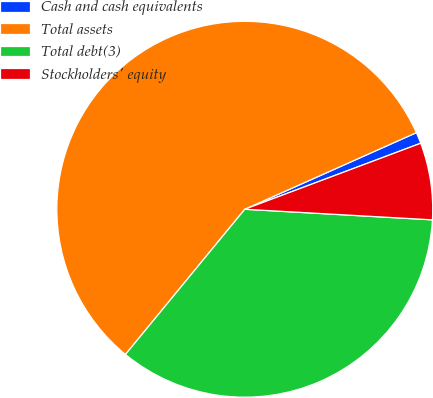<chart> <loc_0><loc_0><loc_500><loc_500><pie_chart><fcel>Cash and cash equivalents<fcel>Total assets<fcel>Total debt(3)<fcel>Stockholders' equity<nl><fcel>0.97%<fcel>57.37%<fcel>35.05%<fcel>6.61%<nl></chart> 